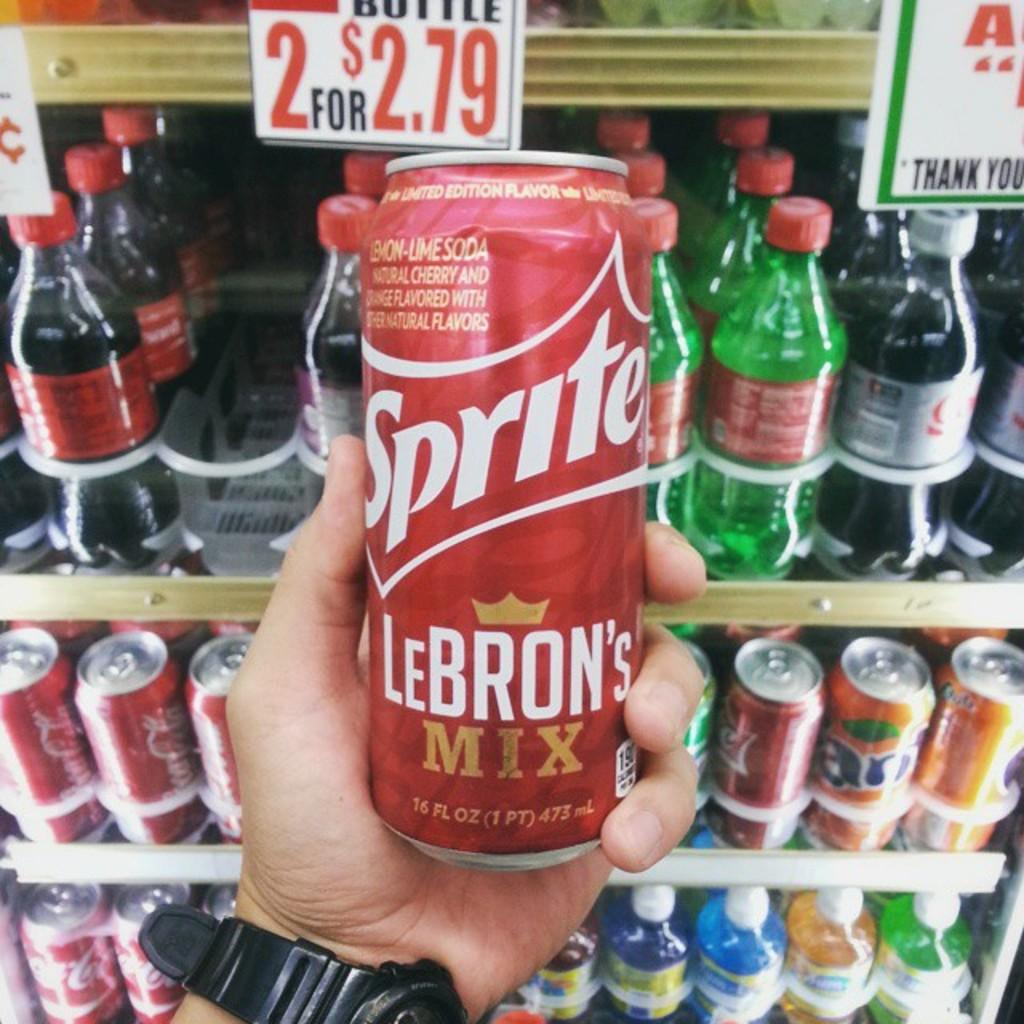<image>
Render a clear and concise summary of the photo. A person is holding a can of Sprite Lebron's Mix. 